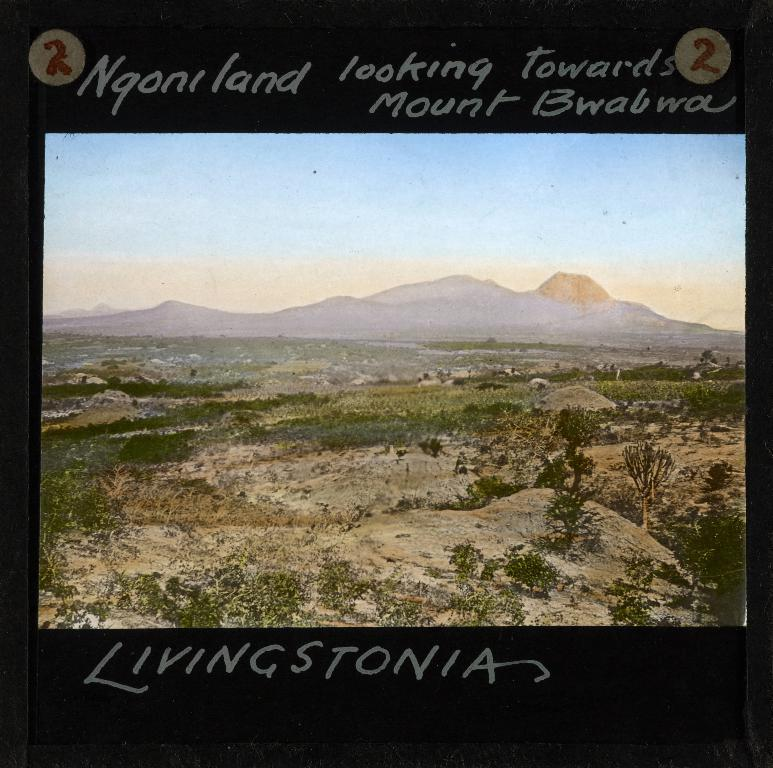<image>
Describe the image concisely. A beautiful picture of a mountain and countryside in Livingstonia. 